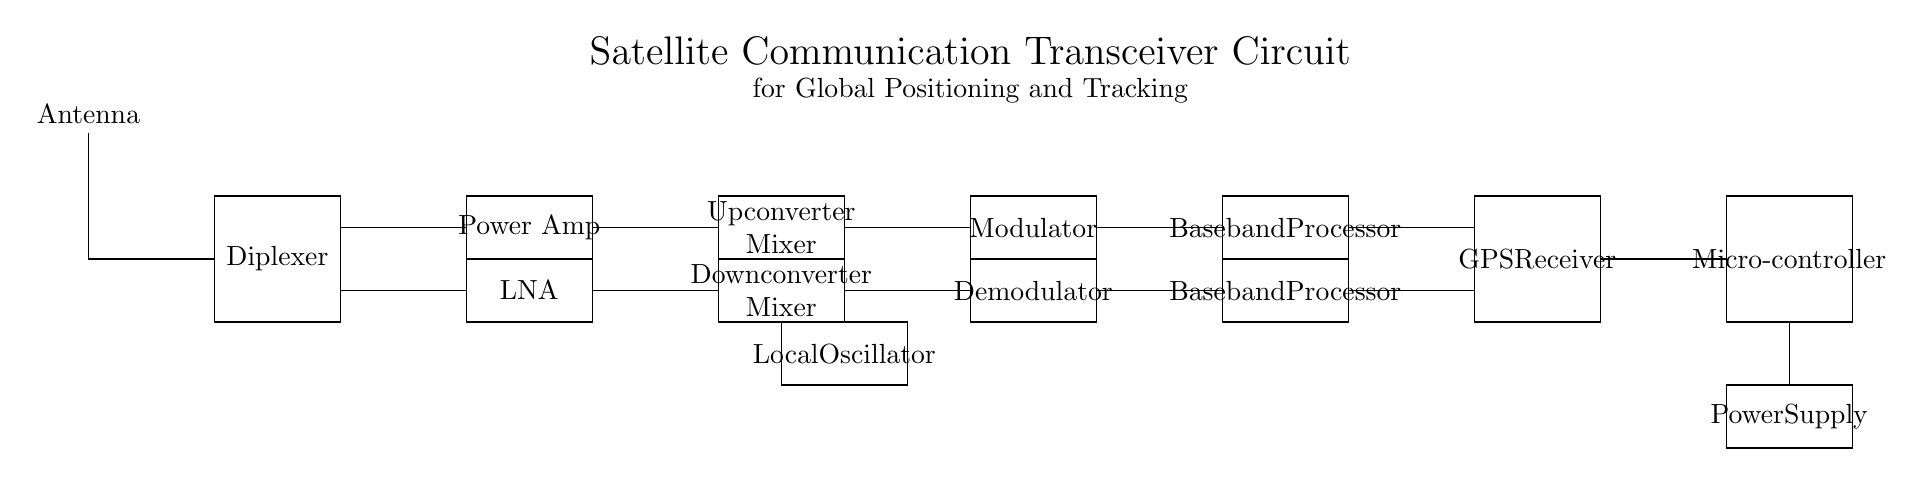What component is used for signal amplification? The component used for signal amplification in this circuit is the Power Amplifier, located in the transmitter path between the Diplexer and the Upconverter Mixer.
Answer: Power Amplifier What does the Diplexer do in the circuit? The Diplexer separates or combines signals for different paths; in this circuit, it allows the antenna to switch between transmitting and receiving modes.
Answer: Separates/combines signals How many processors are present in the circuit? There are two Baseband Processors in the circuit, one in the transmitter path and one in the receiver path.
Answer: Two What is the function of the Local Oscillator? The Local Oscillator generates a frequency that will be mixed with the incoming signal in the Downconverter Mixer, used for tuning and frequency selection.
Answer: Frequency generation In which path is the LNA located? The LNA (Low Noise Amplifier) is located in the receiver path, immediately after the Diplexer and before the Downconverter Mixer.
Answer: Receiver path What type of modulation is processed in this circuit? The Modulator is responsible for modulation in the transmitter path, which is crucial for preparing the signal for transmission.
Answer: Modulation How do the GPS Receiver and Microcontroller interact in the circuit? The GPS Receiver gathers location data and sends it to the Microcontroller for processing and further action within the system.
Answer: Data interaction 